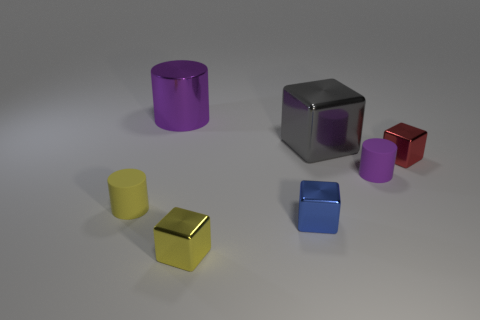Add 2 cylinders. How many objects exist? 9 Subtract all blocks. How many objects are left? 3 Subtract 0 gray cylinders. How many objects are left? 7 Subtract all purple cylinders. Subtract all blue objects. How many objects are left? 4 Add 7 cylinders. How many cylinders are left? 10 Add 7 red things. How many red things exist? 8 